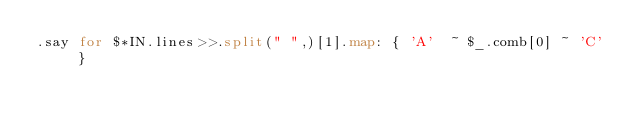<code> <loc_0><loc_0><loc_500><loc_500><_Perl_>.say for $*IN.lines>>.split(" ",)[1].map: { 'A'  ~ $_.comb[0] ~ 'C' }</code> 